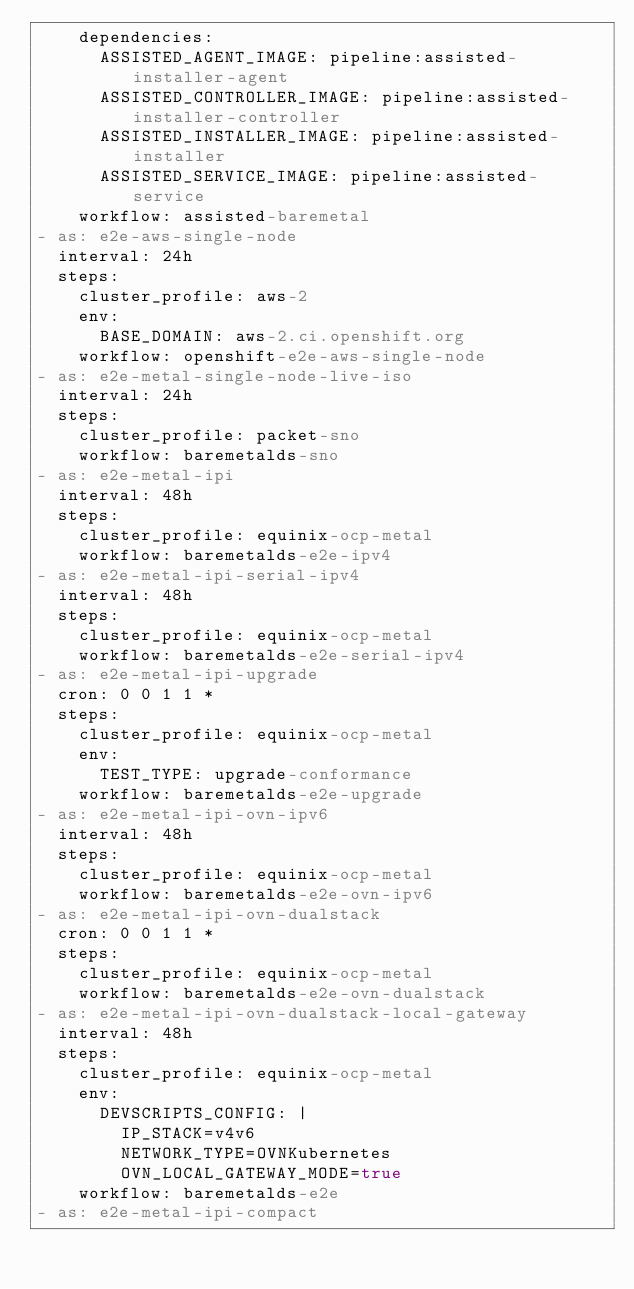Convert code to text. <code><loc_0><loc_0><loc_500><loc_500><_YAML_>    dependencies:
      ASSISTED_AGENT_IMAGE: pipeline:assisted-installer-agent
      ASSISTED_CONTROLLER_IMAGE: pipeline:assisted-installer-controller
      ASSISTED_INSTALLER_IMAGE: pipeline:assisted-installer
      ASSISTED_SERVICE_IMAGE: pipeline:assisted-service
    workflow: assisted-baremetal
- as: e2e-aws-single-node
  interval: 24h
  steps:
    cluster_profile: aws-2
    env:
      BASE_DOMAIN: aws-2.ci.openshift.org
    workflow: openshift-e2e-aws-single-node
- as: e2e-metal-single-node-live-iso
  interval: 24h
  steps:
    cluster_profile: packet-sno
    workflow: baremetalds-sno
- as: e2e-metal-ipi
  interval: 48h
  steps:
    cluster_profile: equinix-ocp-metal
    workflow: baremetalds-e2e-ipv4
- as: e2e-metal-ipi-serial-ipv4
  interval: 48h
  steps:
    cluster_profile: equinix-ocp-metal
    workflow: baremetalds-e2e-serial-ipv4
- as: e2e-metal-ipi-upgrade
  cron: 0 0 1 1 *
  steps:
    cluster_profile: equinix-ocp-metal
    env:
      TEST_TYPE: upgrade-conformance
    workflow: baremetalds-e2e-upgrade
- as: e2e-metal-ipi-ovn-ipv6
  interval: 48h
  steps:
    cluster_profile: equinix-ocp-metal
    workflow: baremetalds-e2e-ovn-ipv6
- as: e2e-metal-ipi-ovn-dualstack
  cron: 0 0 1 1 *
  steps:
    cluster_profile: equinix-ocp-metal
    workflow: baremetalds-e2e-ovn-dualstack
- as: e2e-metal-ipi-ovn-dualstack-local-gateway
  interval: 48h
  steps:
    cluster_profile: equinix-ocp-metal
    env:
      DEVSCRIPTS_CONFIG: |
        IP_STACK=v4v6
        NETWORK_TYPE=OVNKubernetes
        OVN_LOCAL_GATEWAY_MODE=true
    workflow: baremetalds-e2e
- as: e2e-metal-ipi-compact</code> 